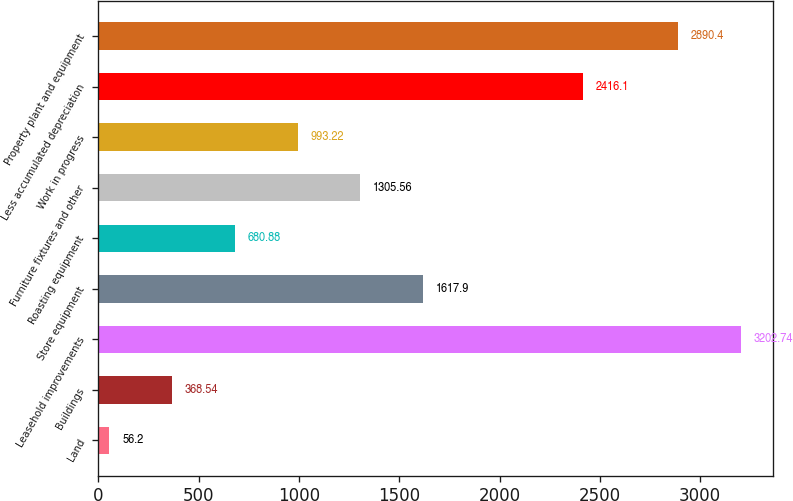Convert chart to OTSL. <chart><loc_0><loc_0><loc_500><loc_500><bar_chart><fcel>Land<fcel>Buildings<fcel>Leasehold improvements<fcel>Store equipment<fcel>Roasting equipment<fcel>Furniture fixtures and other<fcel>Work in progress<fcel>Less accumulated depreciation<fcel>Property plant and equipment<nl><fcel>56.2<fcel>368.54<fcel>3202.74<fcel>1617.9<fcel>680.88<fcel>1305.56<fcel>993.22<fcel>2416.1<fcel>2890.4<nl></chart> 